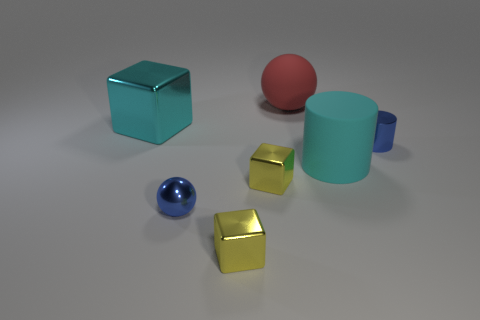Add 3 tiny red matte balls. How many objects exist? 10 Subtract all cubes. How many objects are left? 4 Subtract all tiny blocks. How many blocks are left? 1 Subtract all cyan blocks. How many blocks are left? 2 Subtract 2 yellow blocks. How many objects are left? 5 Subtract 2 cylinders. How many cylinders are left? 0 Subtract all red spheres. Subtract all red cylinders. How many spheres are left? 1 Subtract all blue spheres. How many purple cylinders are left? 0 Subtract all big red matte spheres. Subtract all blue spheres. How many objects are left? 5 Add 3 small blue shiny objects. How many small blue shiny objects are left? 5 